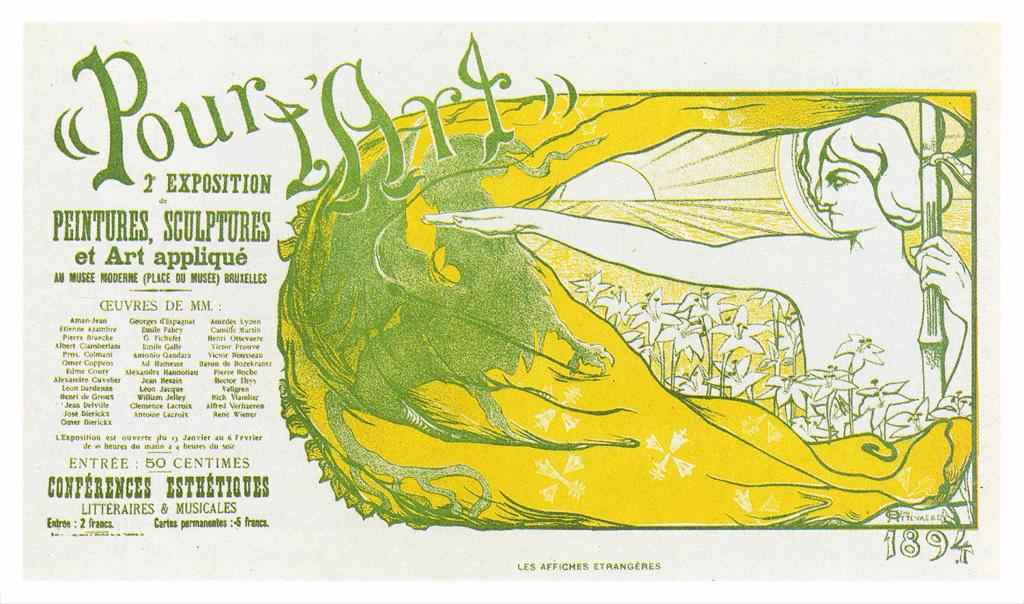Provide a one-sentence caption for the provided image. A french poster with a lady and a green dragon entitled Pour l'Art. 